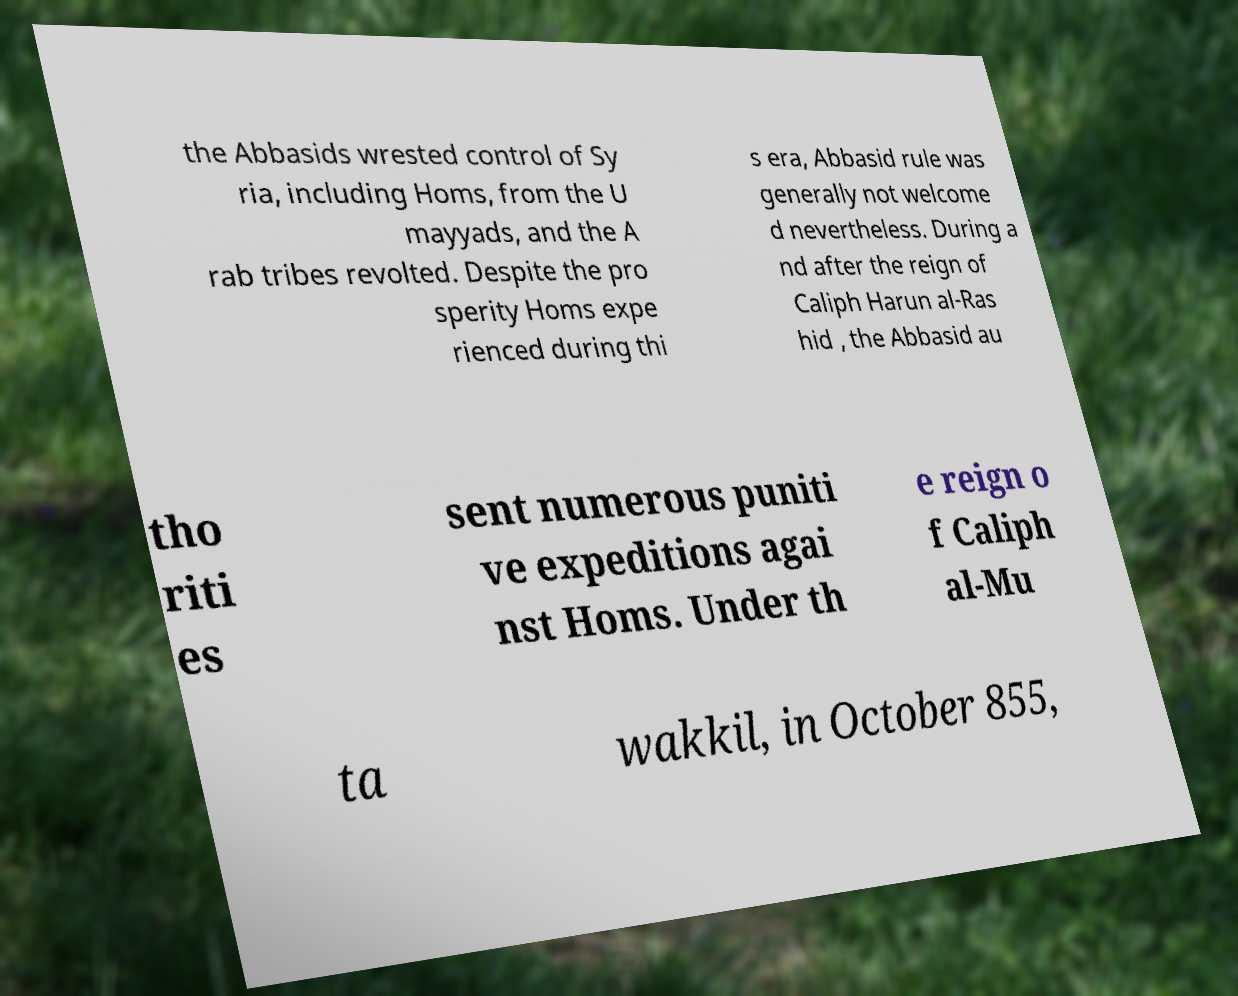There's text embedded in this image that I need extracted. Can you transcribe it verbatim? the Abbasids wrested control of Sy ria, including Homs, from the U mayyads, and the A rab tribes revolted. Despite the pro sperity Homs expe rienced during thi s era, Abbasid rule was generally not welcome d nevertheless. During a nd after the reign of Caliph Harun al-Ras hid , the Abbasid au tho riti es sent numerous puniti ve expeditions agai nst Homs. Under th e reign o f Caliph al-Mu ta wakkil, in October 855, 